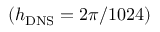Convert formula to latex. <formula><loc_0><loc_0><loc_500><loc_500>\left ( { { h _ { D N S } } = 2 \pi / 1 0 2 4 } \right )</formula> 